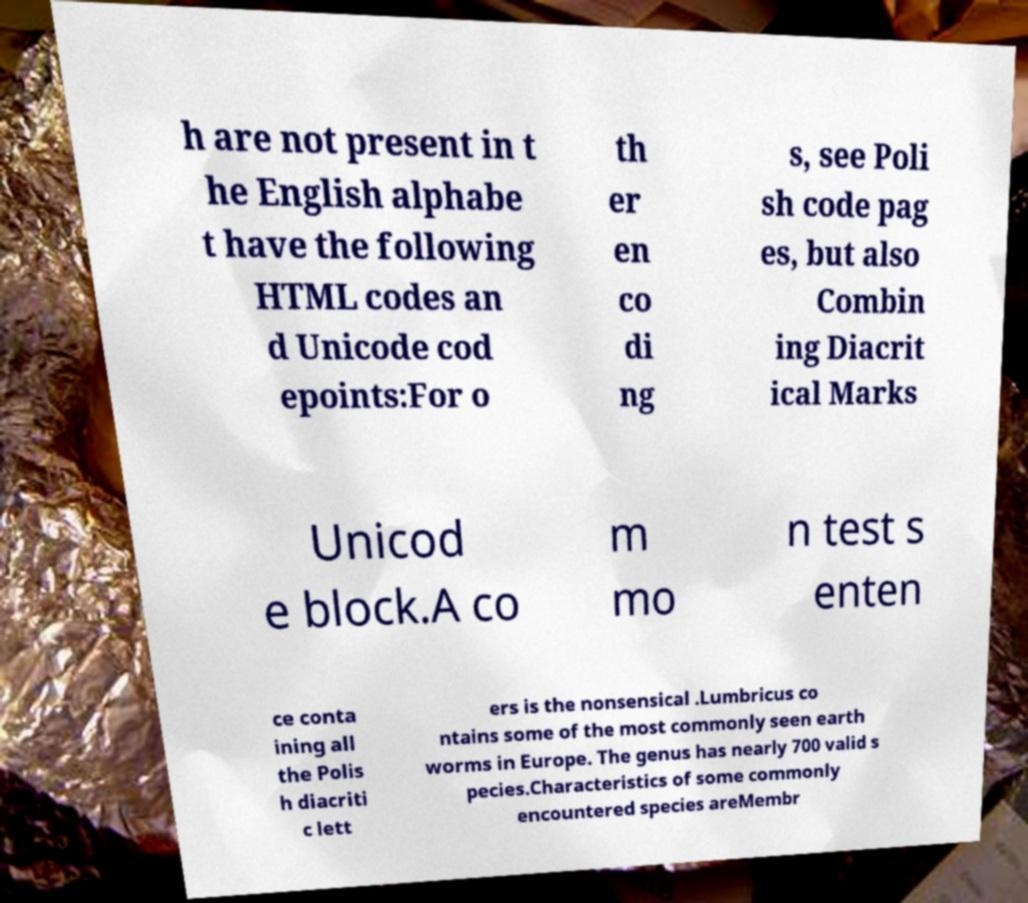Please read and relay the text visible in this image. What does it say? h are not present in t he English alphabe t have the following HTML codes an d Unicode cod epoints:For o th er en co di ng s, see Poli sh code pag es, but also Combin ing Diacrit ical Marks Unicod e block.A co m mo n test s enten ce conta ining all the Polis h diacriti c lett ers is the nonsensical .Lumbricus co ntains some of the most commonly seen earth worms in Europe. The genus has nearly 700 valid s pecies.Characteristics of some commonly encountered species areMembr 